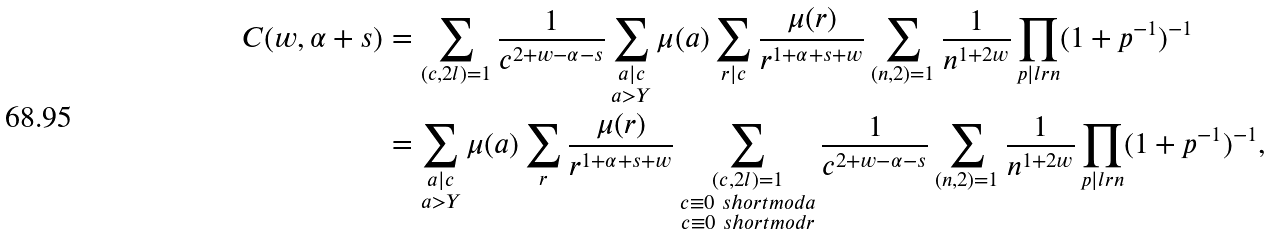<formula> <loc_0><loc_0><loc_500><loc_500>C ( w , \alpha + s ) & = \sum _ { ( c , 2 l ) = 1 } \frac { 1 } { c ^ { 2 + w - \alpha - s } } \sum _ { \substack { a | c \\ a > Y } } \mu ( a ) \sum _ { r | c } \frac { \mu ( r ) } { r ^ { 1 + \alpha + s + w } } \sum _ { ( n , 2 ) = 1 } \frac { 1 } { n ^ { 1 + 2 w } } \prod _ { p | l r n } ( 1 + p ^ { - 1 } ) ^ { - 1 } \\ & = \sum _ { \substack { a | c \\ a > Y } } \mu ( a ) \sum _ { r } \frac { \mu ( r ) } { r ^ { 1 + \alpha + s + w } } \sum _ { \substack { ( c , 2 l ) = 1 \\ c \equiv 0 \ s h o r t m o d { a } \\ c \equiv 0 \ s h o r t m o d { r } } } \frac { 1 } { c ^ { 2 + w - \alpha - s } } \sum _ { ( n , 2 ) = 1 } \frac { 1 } { n ^ { 1 + 2 w } } \prod _ { p | l r n } ( 1 + p ^ { - 1 } ) ^ { - 1 } ,</formula> 